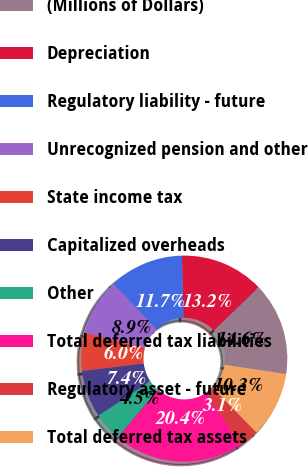Convert chart to OTSL. <chart><loc_0><loc_0><loc_500><loc_500><pie_chart><fcel>(Millions of Dollars)<fcel>Depreciation<fcel>Regulatory liability - future<fcel>Unrecognized pension and other<fcel>State income tax<fcel>Capitalized overheads<fcel>Other<fcel>Total deferred tax liabilities<fcel>Regulatory asset - future<fcel>Total deferred tax assets<nl><fcel>14.6%<fcel>13.16%<fcel>11.73%<fcel>8.85%<fcel>5.97%<fcel>7.41%<fcel>4.53%<fcel>20.36%<fcel>3.1%<fcel>10.29%<nl></chart> 